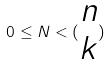<formula> <loc_0><loc_0><loc_500><loc_500>0 \leq N < ( \begin{matrix} n \\ k \end{matrix} )</formula> 